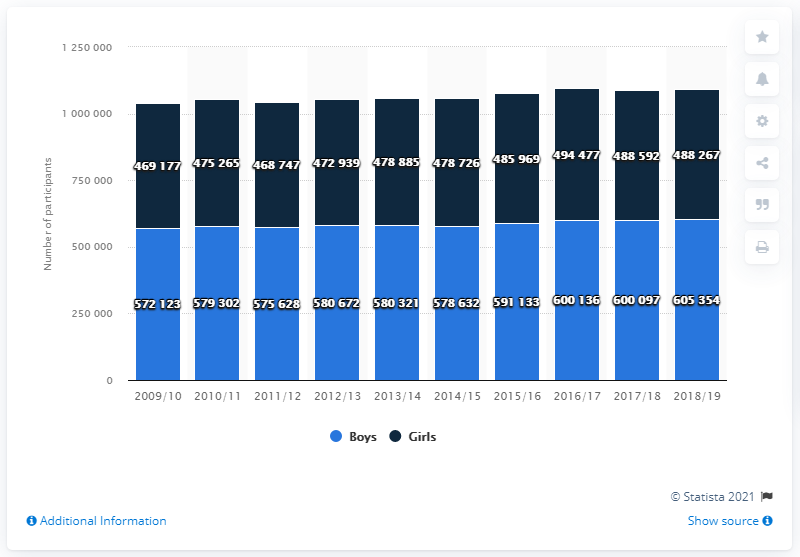Indicate a few pertinent items in this graphic. The maximum number of boys who participated in U.S. high school track and field occurred between the years 2018/19. The percentage of maximum boys participants over the years has been 136607, and the minimum girl participants over the years has been the least at 136607. In the 2018/19 high school track and field season, a total of 488,267 girls participated. 